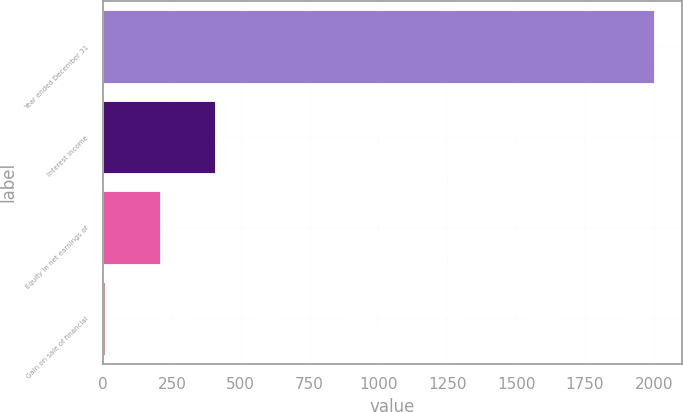<chart> <loc_0><loc_0><loc_500><loc_500><bar_chart><fcel>Year ended December 31<fcel>Interest income<fcel>Equity in net earnings of<fcel>Gain on sale of financial<nl><fcel>2002<fcel>405.2<fcel>205.6<fcel>6<nl></chart> 